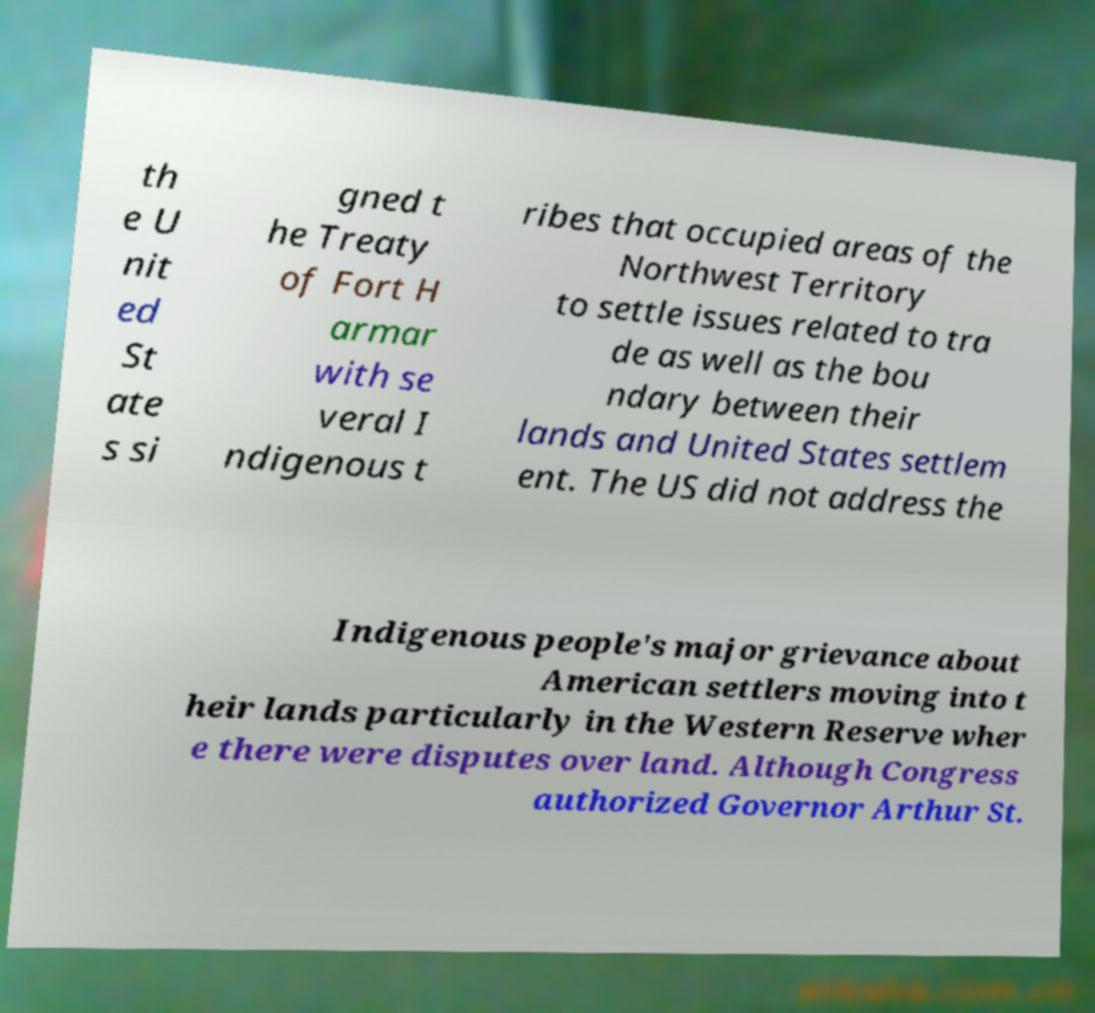Can you accurately transcribe the text from the provided image for me? th e U nit ed St ate s si gned t he Treaty of Fort H armar with se veral I ndigenous t ribes that occupied areas of the Northwest Territory to settle issues related to tra de as well as the bou ndary between their lands and United States settlem ent. The US did not address the Indigenous people's major grievance about American settlers moving into t heir lands particularly in the Western Reserve wher e there were disputes over land. Although Congress authorized Governor Arthur St. 